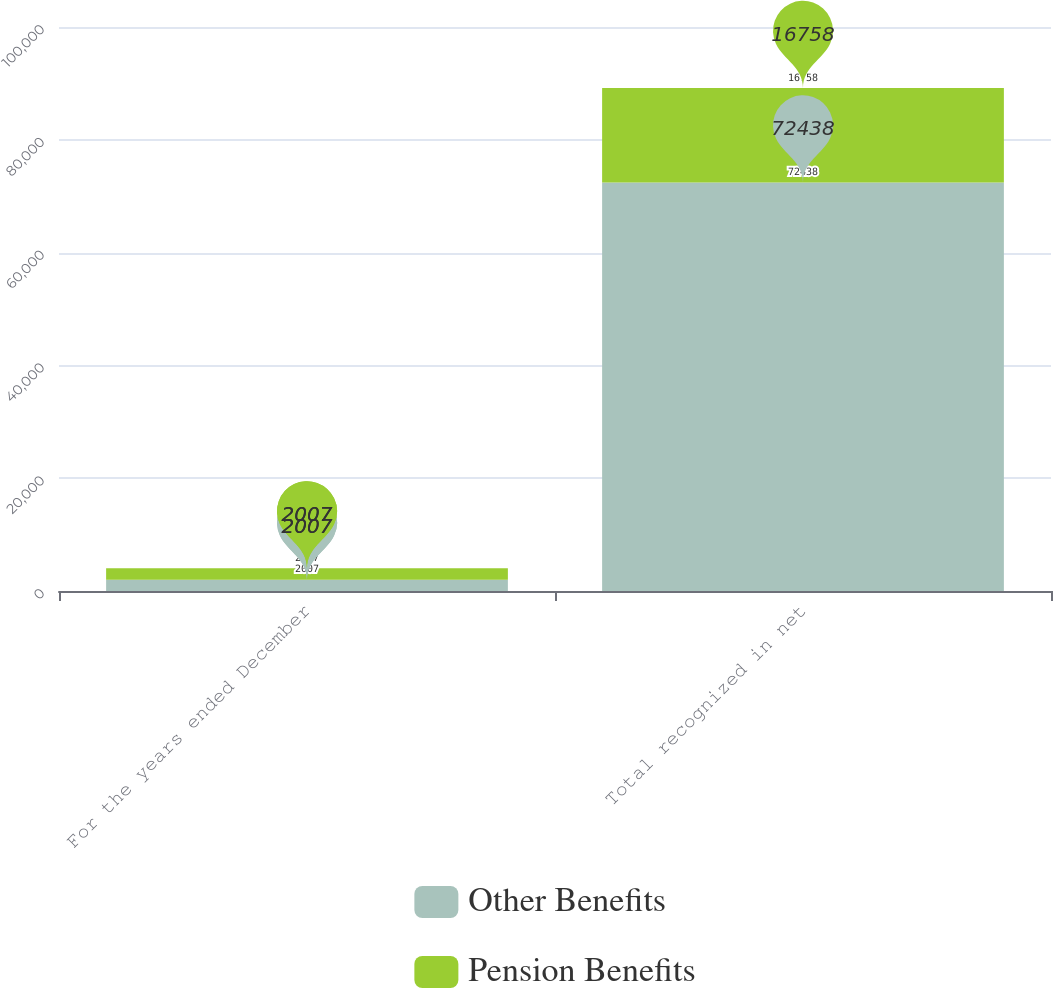Convert chart. <chart><loc_0><loc_0><loc_500><loc_500><stacked_bar_chart><ecel><fcel>For the years ended December<fcel>Total recognized in net<nl><fcel>Other Benefits<fcel>2007<fcel>72438<nl><fcel>Pension Benefits<fcel>2007<fcel>16758<nl></chart> 